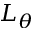Convert formula to latex. <formula><loc_0><loc_0><loc_500><loc_500>L _ { \theta }</formula> 